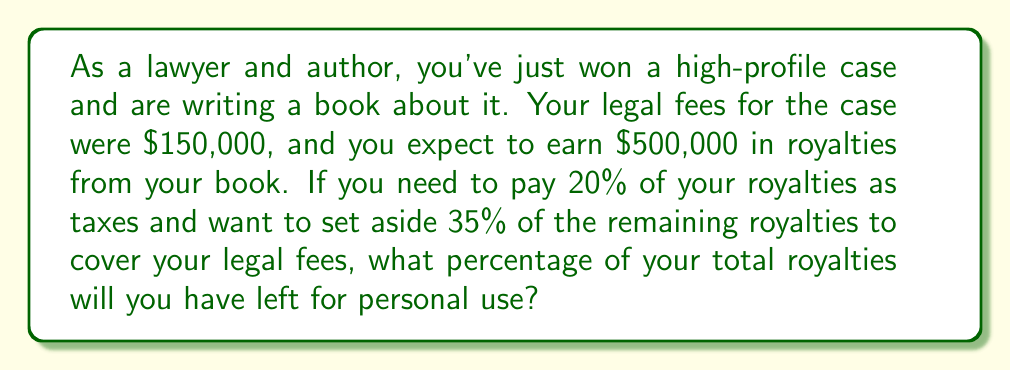Provide a solution to this math problem. Let's break this down step-by-step:

1. Calculate the royalties after taxes:
   * Total royalties: $500,000
   * Taxes: 20% of $500,000 = $500,000 * 0.20 = $100,000
   * Royalties after taxes: $500,000 - $100,000 = $400,000

2. Calculate the amount set aside for legal fees:
   * 35% of remaining royalties: $400,000 * 0.35 = $140,000

3. Calculate the amount left for personal use:
   * Remaining amount: $400,000 - $140,000 = $260,000

4. Calculate the percentage of total royalties left for personal use:
   * Percentage = (Amount for personal use / Total royalties) * 100
   * Percentage = ($260,000 / $500,000) * 100
   
   Let's solve this using LaTeX:
   
   $$\text{Percentage} = \frac{260,000}{500,000} * 100 = 0.52 * 100 = 52\%$$

Therefore, 52% of your total royalties will be left for personal use.
Answer: 52% 